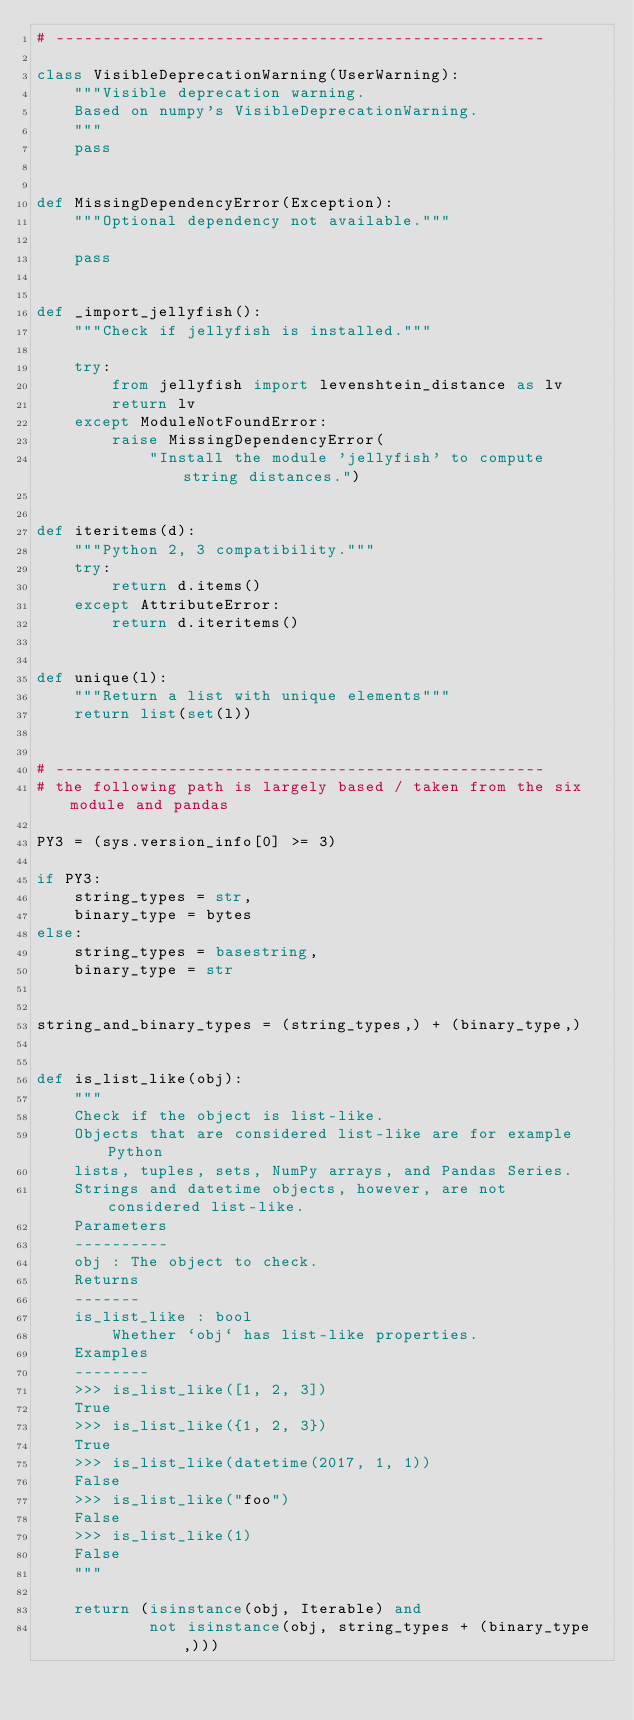<code> <loc_0><loc_0><loc_500><loc_500><_Python_># ----------------------------------------------------

class VisibleDeprecationWarning(UserWarning):
    """Visible deprecation warning.
    Based on numpy's VisibleDeprecationWarning.
    """
    pass


def MissingDependencyError(Exception):
    """Optional dependency not available."""

    pass


def _import_jellyfish():
    """Check if jellyfish is installed."""

    try:
        from jellyfish import levenshtein_distance as lv
        return lv
    except ModuleNotFoundError:
        raise MissingDependencyError(
            "Install the module 'jellyfish' to compute string distances.")


def iteritems(d):
    """Python 2, 3 compatibility."""
    try:
        return d.items()
    except AttributeError:
        return d.iteritems()


def unique(l):
    """Return a list with unique elements"""
    return list(set(l))


# ----------------------------------------------------
# the following path is largely based / taken from the six module and pandas

PY3 = (sys.version_info[0] >= 3)

if PY3:
    string_types = str,
    binary_type = bytes
else:
    string_types = basestring,
    binary_type = str


string_and_binary_types = (string_types,) + (binary_type,)


def is_list_like(obj):
    """
    Check if the object is list-like.
    Objects that are considered list-like are for example Python
    lists, tuples, sets, NumPy arrays, and Pandas Series.
    Strings and datetime objects, however, are not considered list-like.
    Parameters
    ----------
    obj : The object to check.
    Returns
    -------
    is_list_like : bool
        Whether `obj` has list-like properties.
    Examples
    --------
    >>> is_list_like([1, 2, 3])
    True
    >>> is_list_like({1, 2, 3})
    True
    >>> is_list_like(datetime(2017, 1, 1))
    False
    >>> is_list_like("foo")
    False
    >>> is_list_like(1)
    False
    """

    return (isinstance(obj, Iterable) and
            not isinstance(obj, string_types + (binary_type,)))

</code> 